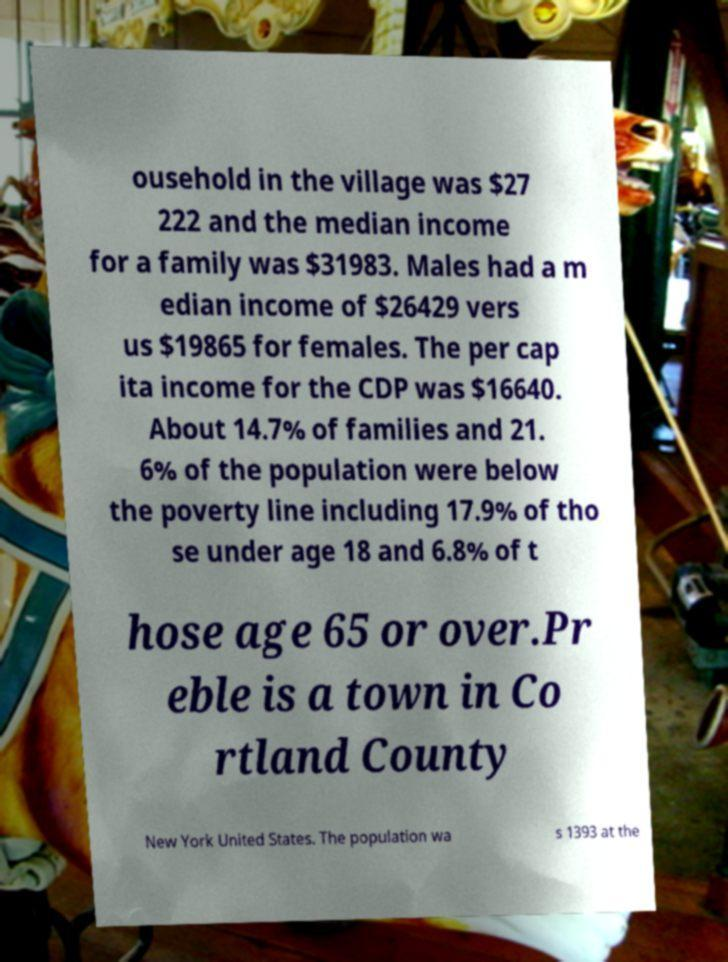What messages or text are displayed in this image? I need them in a readable, typed format. ousehold in the village was $27 222 and the median income for a family was $31983. Males had a m edian income of $26429 vers us $19865 for females. The per cap ita income for the CDP was $16640. About 14.7% of families and 21. 6% of the population were below the poverty line including 17.9% of tho se under age 18 and 6.8% of t hose age 65 or over.Pr eble is a town in Co rtland County New York United States. The population wa s 1393 at the 